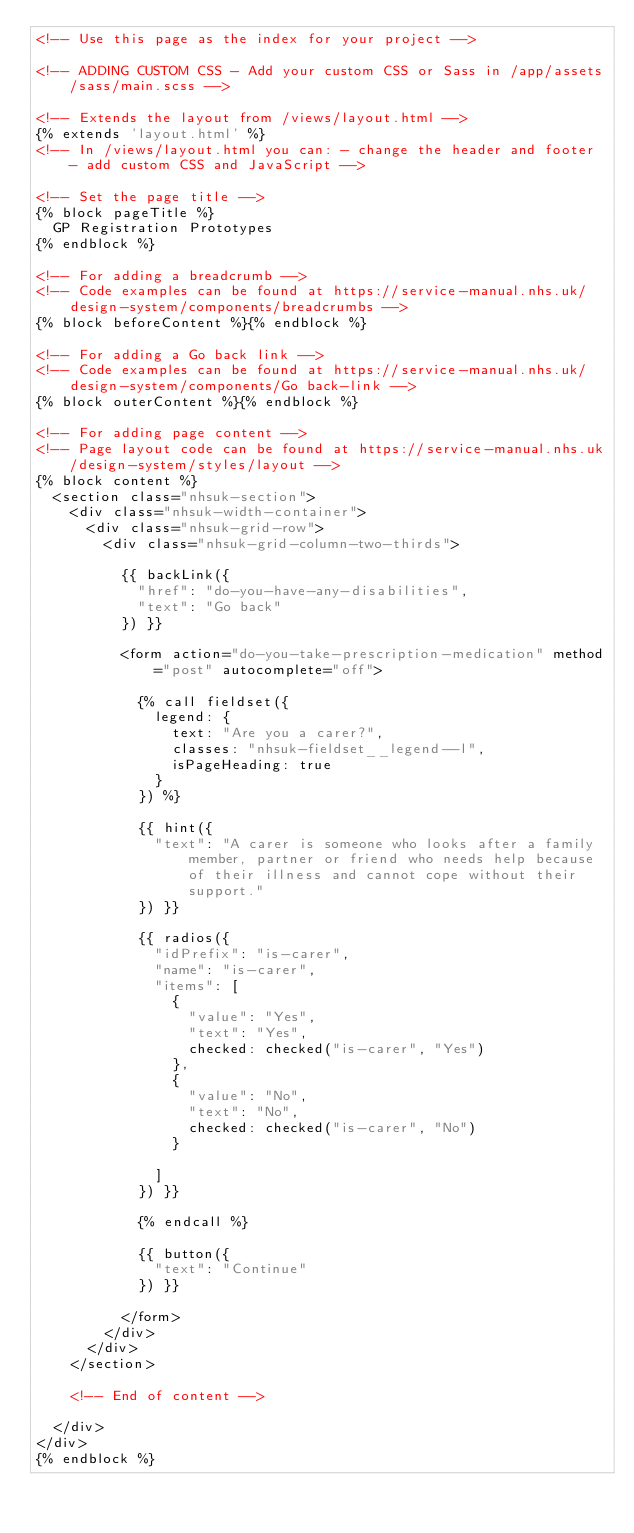Convert code to text. <code><loc_0><loc_0><loc_500><loc_500><_HTML_><!-- Use this page as the index for your project -->

<!-- ADDING CUSTOM CSS - Add your custom CSS or Sass in /app/assets/sass/main.scss -->

<!-- Extends the layout from /views/layout.html -->
{% extends 'layout.html' %}
<!-- In /views/layout.html you can: - change the header and footer - add custom CSS and JavaScript -->

<!-- Set the page title -->
{% block pageTitle %}
  GP Registration Prototypes
{% endblock %}

<!-- For adding a breadcrumb -->
<!-- Code examples can be found at https://service-manual.nhs.uk/design-system/components/breadcrumbs -->
{% block beforeContent %}{% endblock %}

<!-- For adding a Go back link -->
<!-- Code examples can be found at https://service-manual.nhs.uk/design-system/components/Go back-link -->
{% block outerContent %}{% endblock %}

<!-- For adding page content -->
<!-- Page layout code can be found at https://service-manual.nhs.uk/design-system/styles/layout -->
{% block content %}
  <section class="nhsuk-section">
    <div class="nhsuk-width-container">
      <div class="nhsuk-grid-row">
        <div class="nhsuk-grid-column-two-thirds">

          {{ backLink({
            "href": "do-you-have-any-disabilities",
            "text": "Go back"
          }) }}

          <form action="do-you-take-prescription-medication" method="post" autocomplete="off">

            {% call fieldset({
              legend: {
                text: "Are you a carer?",
                classes: "nhsuk-fieldset__legend--l",
                isPageHeading: true
              }
            }) %}

            {{ hint({
              "text": "A carer is someone who looks after a family member, partner or friend who needs help because of their illness and cannot cope without their support."
            }) }}

            {{ radios({
              "idPrefix": "is-carer",
              "name": "is-carer",
              "items": [
                {
                  "value": "Yes",
                  "text": "Yes",
                  checked: checked("is-carer", "Yes")
                },
                {
                  "value": "No",
                  "text": "No",
                  checked: checked("is-carer", "No")
                }

              ]
            }) }}

            {% endcall %}

            {{ button({
              "text": "Continue"
            }) }}

          </form>
        </div>
      </div>
    </section>

    <!-- End of content -->

  </div>
</div>
{% endblock %}
</code> 